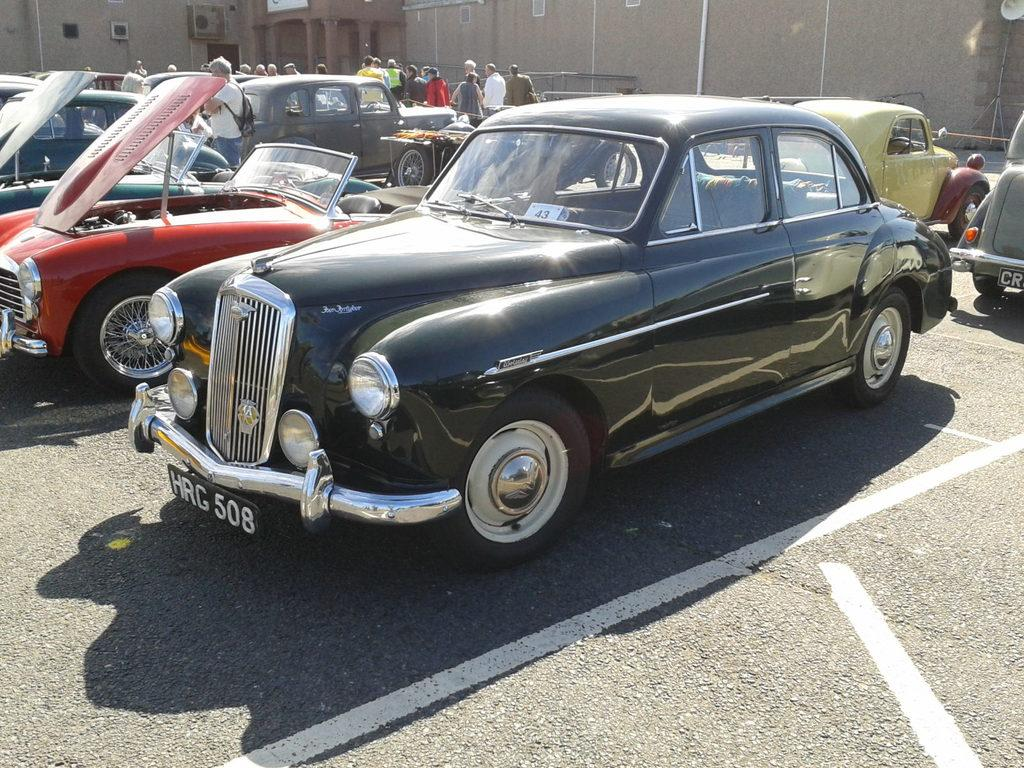What type of vehicles can be seen in the image? There are cars in the image. What are the people in the image doing? People are standing on the ground in the image. What can be seen in the distance in the image? There are buildings in the background of the image. What markings are visible on the road in the image? White color lines are visible on the road in the image. What type of sister is standing next to the car in the image? There is no sister present in the image; only people are standing on the ground. 